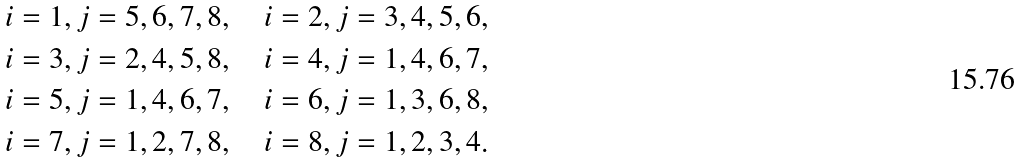Convert formula to latex. <formula><loc_0><loc_0><loc_500><loc_500>& i = 1 , j = 5 , 6 , 7 , 8 , \quad i = 2 , j = 3 , 4 , 5 , 6 , \\ & i = 3 , j = 2 , 4 , 5 , 8 , \quad i = 4 , j = 1 , 4 , 6 , 7 , \\ & i = 5 , j = 1 , 4 , 6 , 7 , \quad i = 6 , j = 1 , 3 , 6 , 8 , \\ & i = 7 , j = 1 , 2 , 7 , 8 , \quad i = 8 , j = 1 , 2 , 3 , 4 .</formula> 